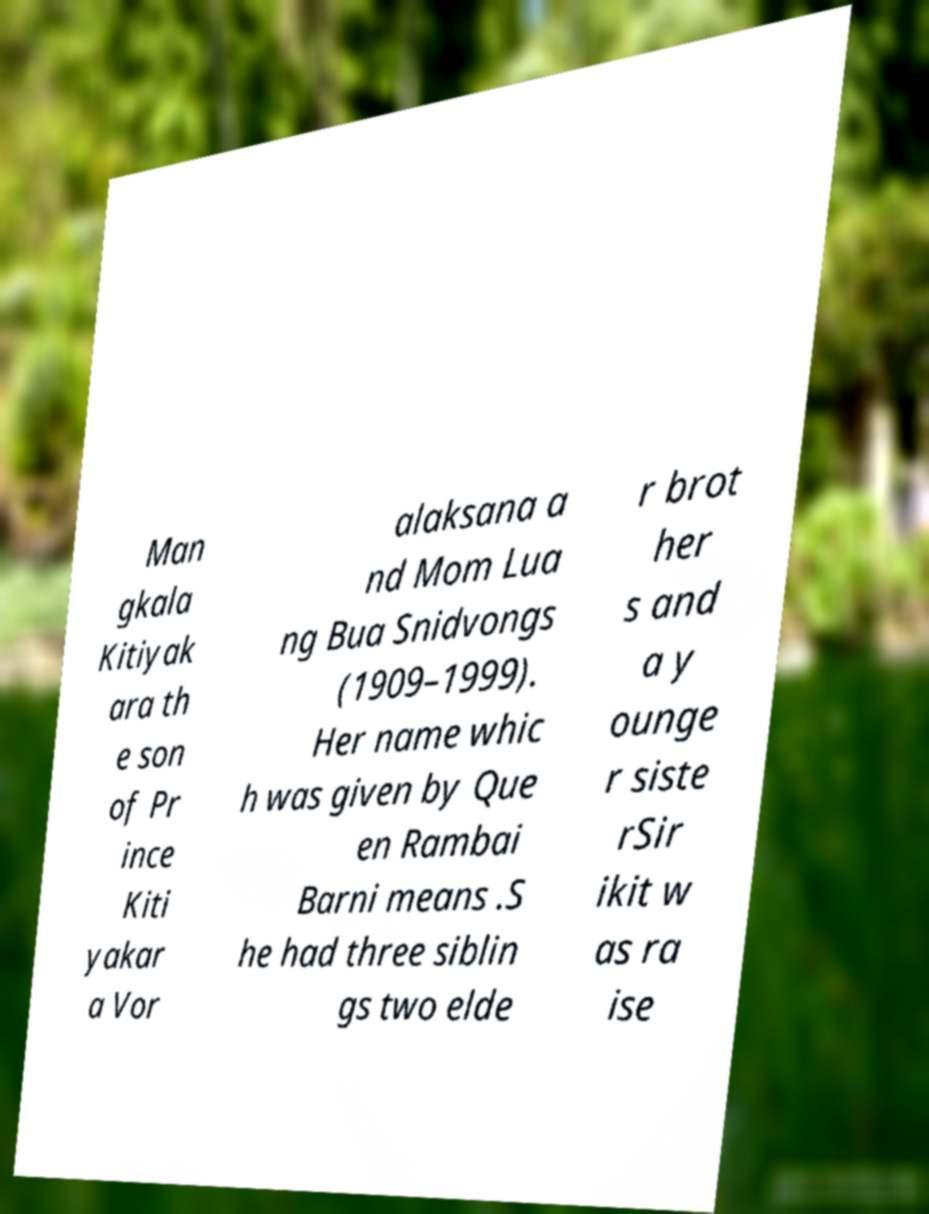Can you read and provide the text displayed in the image?This photo seems to have some interesting text. Can you extract and type it out for me? Man gkala Kitiyak ara th e son of Pr ince Kiti yakar a Vor alaksana a nd Mom Lua ng Bua Snidvongs (1909–1999). Her name whic h was given by Que en Rambai Barni means .S he had three siblin gs two elde r brot her s and a y ounge r siste rSir ikit w as ra ise 